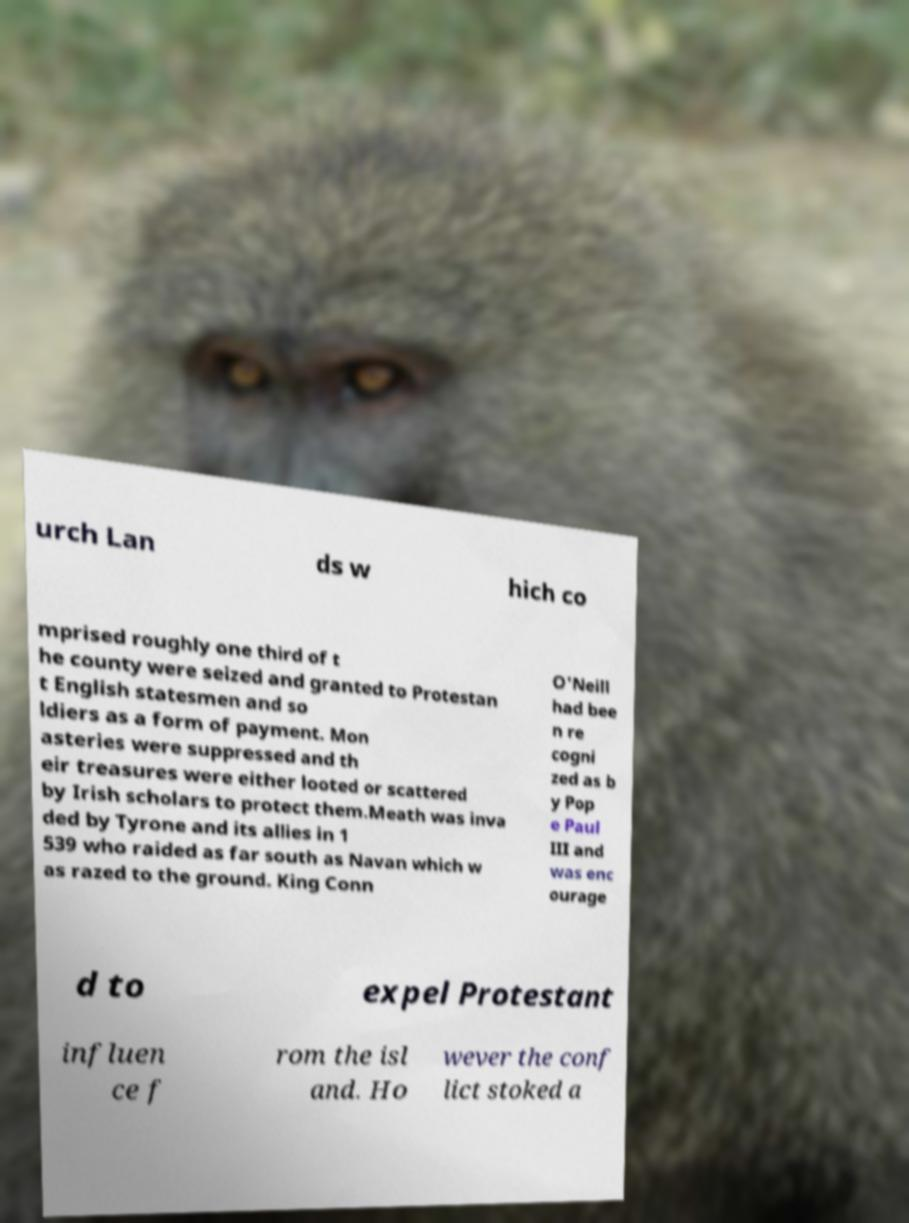What messages or text are displayed in this image? I need them in a readable, typed format. urch Lan ds w hich co mprised roughly one third of t he county were seized and granted to Protestan t English statesmen and so ldiers as a form of payment. Mon asteries were suppressed and th eir treasures were either looted or scattered by Irish scholars to protect them.Meath was inva ded by Tyrone and its allies in 1 539 who raided as far south as Navan which w as razed to the ground. King Conn O'Neill had bee n re cogni zed as b y Pop e Paul III and was enc ourage d to expel Protestant influen ce f rom the isl and. Ho wever the conf lict stoked a 